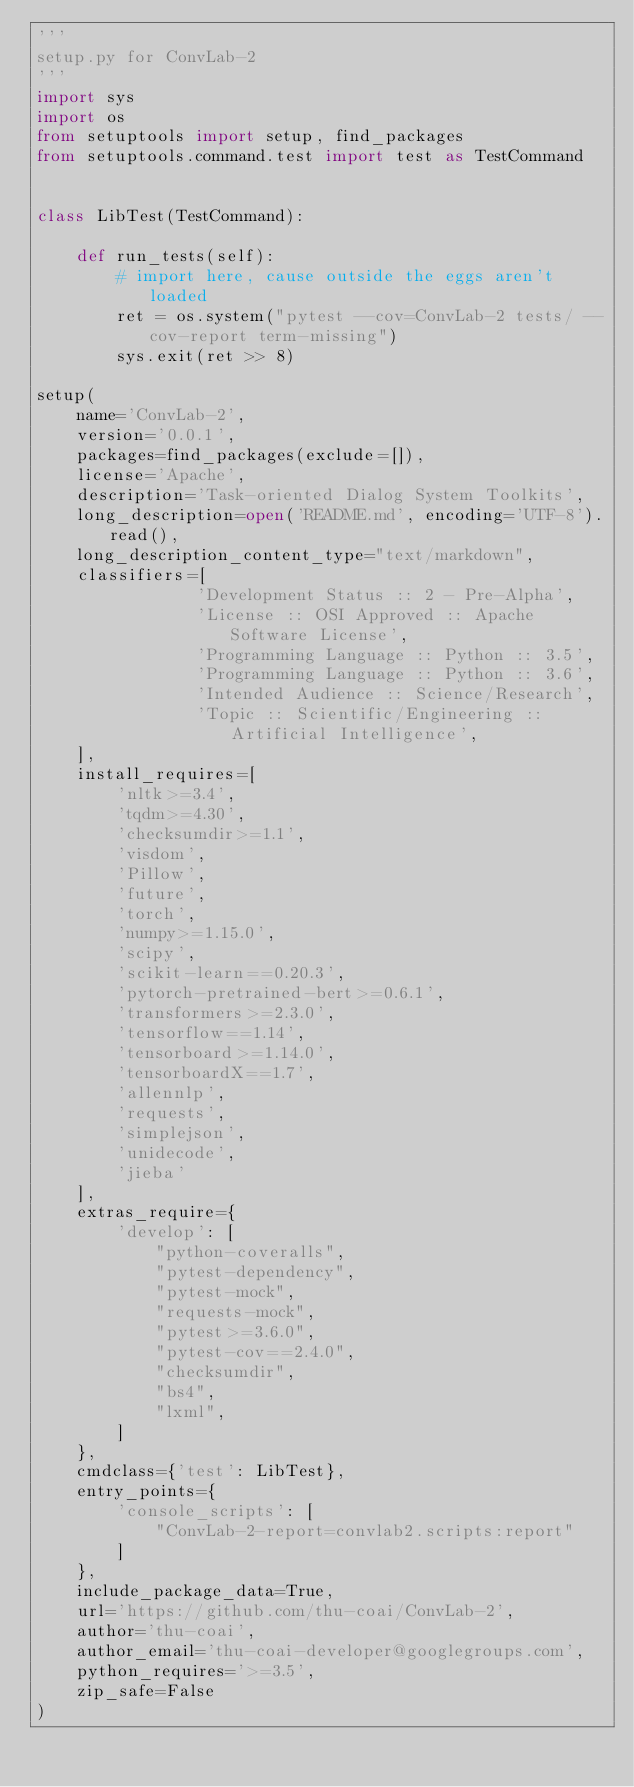<code> <loc_0><loc_0><loc_500><loc_500><_Python_>'''
setup.py for ConvLab-2
'''
import sys
import os
from setuptools import setup, find_packages
from setuptools.command.test import test as TestCommand


class LibTest(TestCommand):

    def run_tests(self):
        # import here, cause outside the eggs aren't loaded
        ret = os.system("pytest --cov=ConvLab-2 tests/ --cov-report term-missing")
        sys.exit(ret >> 8)

setup(
    name='ConvLab-2',
    version='0.0.1',
    packages=find_packages(exclude=[]),
    license='Apache',
    description='Task-oriented Dialog System Toolkits',
    long_description=open('README.md', encoding='UTF-8').read(),
    long_description_content_type="text/markdown",
    classifiers=[
                'Development Status :: 2 - Pre-Alpha',
                'License :: OSI Approved :: Apache Software License',
                'Programming Language :: Python :: 3.5',
                'Programming Language :: Python :: 3.6',
                'Intended Audience :: Science/Research',
                'Topic :: Scientific/Engineering :: Artificial Intelligence',
    ],
    install_requires=[
        'nltk>=3.4',
        'tqdm>=4.30',
        'checksumdir>=1.1',
        'visdom',
        'Pillow',
        'future',
        'torch',
        'numpy>=1.15.0',
        'scipy',
        'scikit-learn==0.20.3',
        'pytorch-pretrained-bert>=0.6.1',
        'transformers>=2.3.0',
        'tensorflow==1.14',
        'tensorboard>=1.14.0',
        'tensorboardX==1.7',
        'allennlp',
        'requests',
        'simplejson',
        'unidecode',
        'jieba'
    ],
    extras_require={
        'develop': [
            "python-coveralls",
            "pytest-dependency",
            "pytest-mock",
            "requests-mock",
            "pytest>=3.6.0",
            "pytest-cov==2.4.0",
            "checksumdir",
            "bs4",
            "lxml",
        ]
    },
    cmdclass={'test': LibTest},
    entry_points={
        'console_scripts': [
            "ConvLab-2-report=convlab2.scripts:report"
        ]
    },
    include_package_data=True,
    url='https://github.com/thu-coai/ConvLab-2',
    author='thu-coai',
    author_email='thu-coai-developer@googlegroups.com',
    python_requires='>=3.5',
    zip_safe=False
)
</code> 